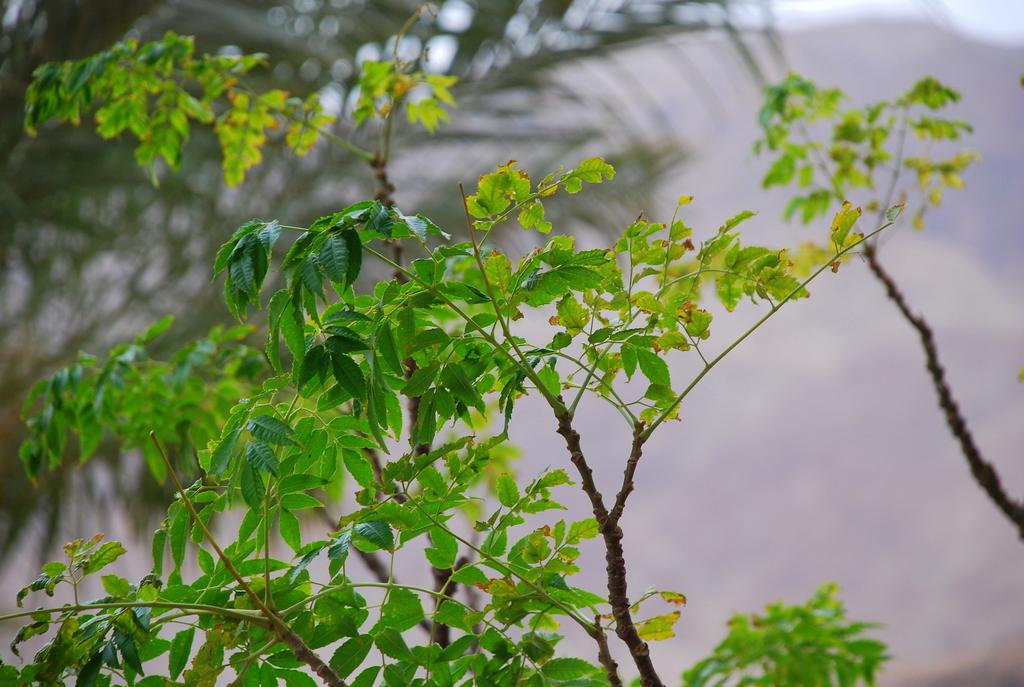What type of plant is depicted in the image? The image contains branches of a plant. What color are the leaves on the plant? The leaves visible in the image are green. Can you describe the background of the image? There is a tree in the background on the left side. How many kittens can be seen attempting to climb the tree in the image? There are no kittens present in the image, and therefore no such activity can be observed. 